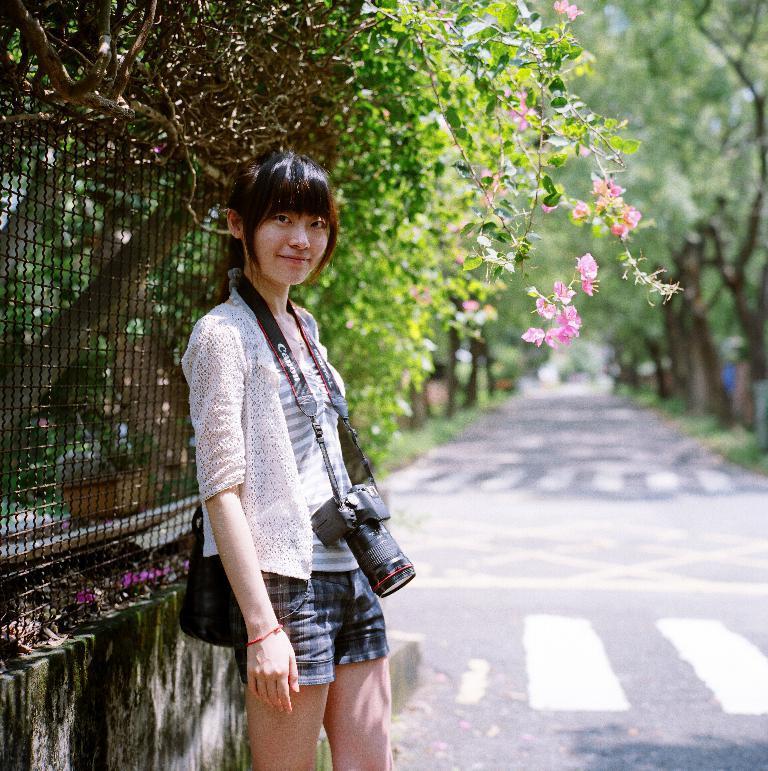Please provide a concise description of this image. In this image I can see the person standing and wearing the white, ash and blue color dress and also wearing the camera. She is on the road. To the left I can see the railing and the plants. There are the pink color flowers to the plants. In the background there are many trees. 